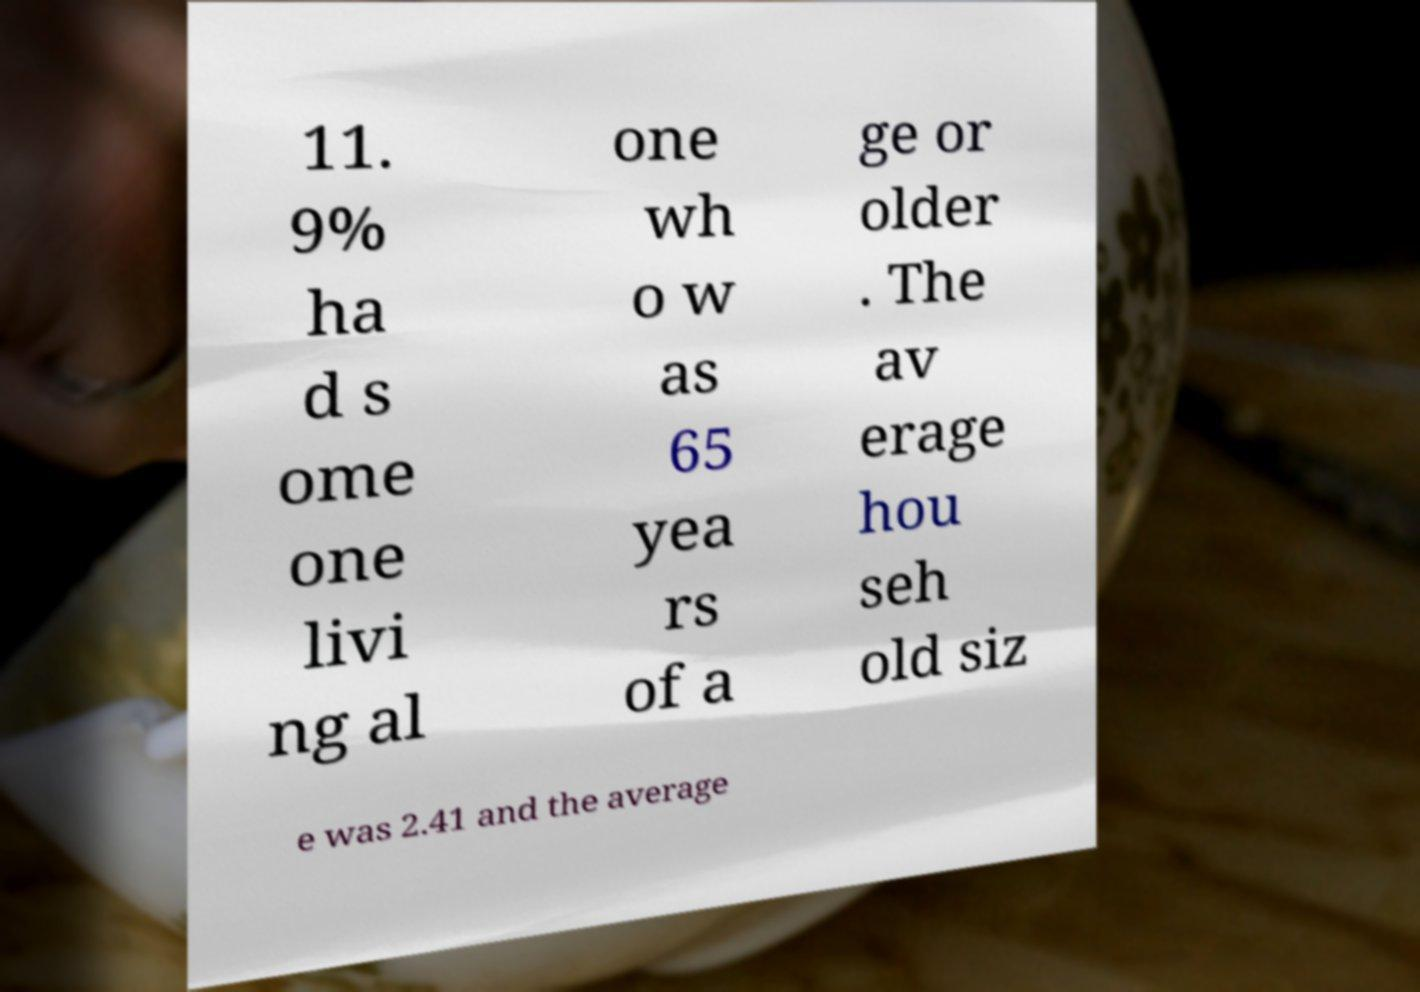Could you extract and type out the text from this image? 11. 9% ha d s ome one livi ng al one wh o w as 65 yea rs of a ge or older . The av erage hou seh old siz e was 2.41 and the average 